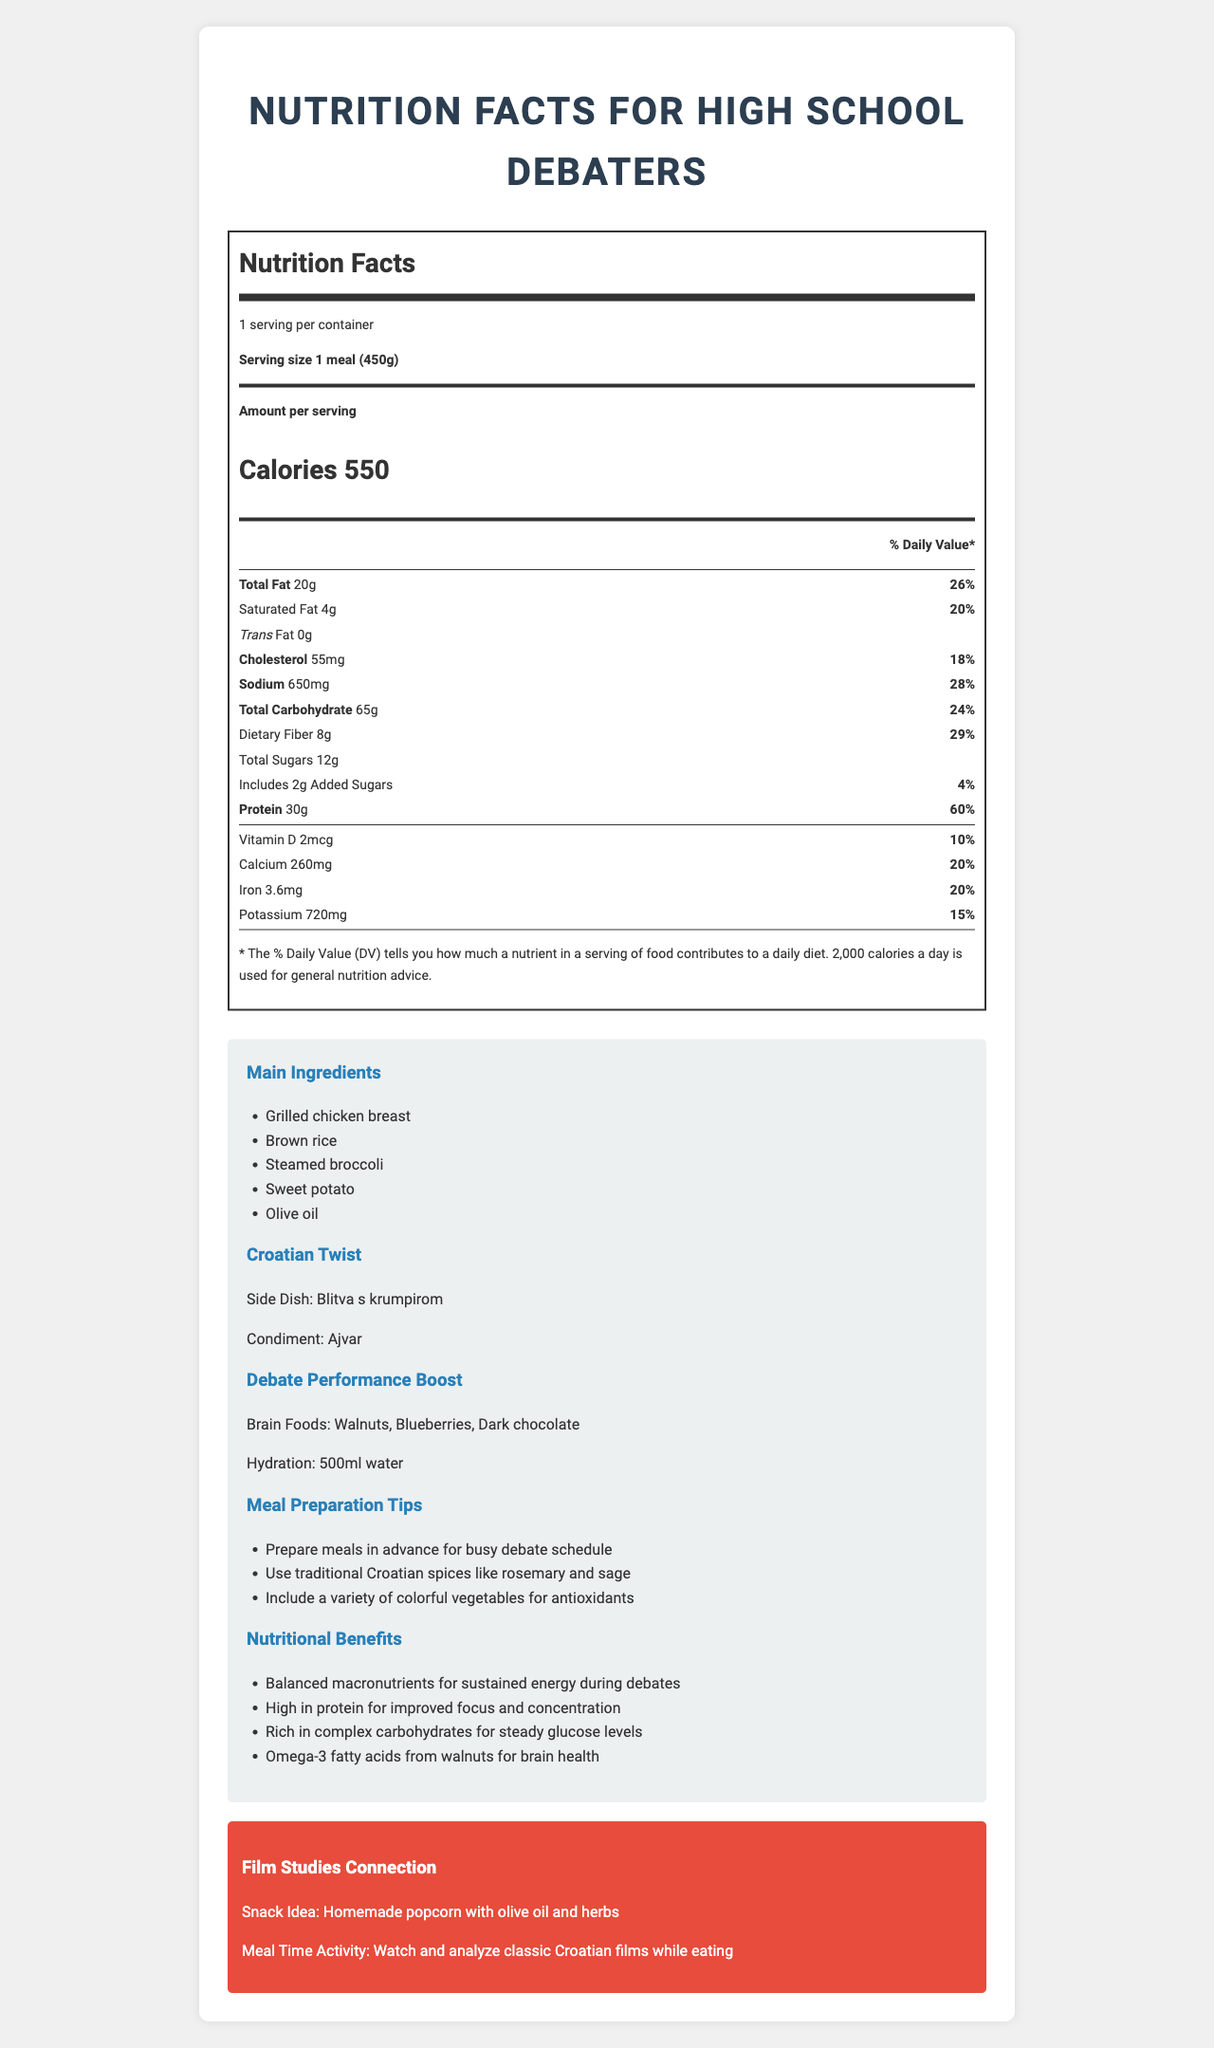What is the serving size for this meal? The document specifies the serving size as "1 meal (450g)" under the Nutrition Facts section.
Answer: 1 meal (450g) How many calories does one serving contain? The document states that one serving contains 550 calories.
Answer: 550 What is the main source of protein in this meal? According to the list of main ingredients, grilled chicken breast is mentioned first, indicating it is a primary ingredient and source of protein.
Answer: Grilled chicken breast What percentage of daily sodium intake does this meal provide? The document under the Sodium section shows that this meal provides 28% of the daily value for sodium.
Answer: 28% List three "brain foods" included in the meal to boost debate performance. The Debate Performance Boost section lists these foods specifically as brain foods.
Answer: Walnuts, Blueberries, Dark chocolate Which of the following is a condiment in the Croatian twist for this meal? A. Blitva s krumpirom B. Ajvar C. Olive oil D. Sweet potato The Croatian Twist section lists Ajvar as the condiment.
Answer: B How much added sugar is in one serving of this meal? The Nutrition Facts section includes the amount of added sugars, which is 2 grams.
Answer: 2g What is the main idea of the document? The document provides detailed nutritional facts, meal preparation tips, Croatian twists, and explains the benefits of the meal for high school debaters, including brain foods and hydration suggestions.
Answer: Nutritional information and benefits for a balanced meal designed for high school debaters Does this meal include any trans fat? The document specifies that the amount of trans fat in the meal is 0 grams.
Answer: No How much dietary fiber does one serving contain? The Nutrition Facts section under Dietary Fiber indicates that one serving contains 8 grams of dietary fiber.
Answer: 8g Can you determine the price of the meal from the document? The document provides nutritional information and preparation tips but does not include any pricing information.
Answer: Cannot be determined Which activity is suggested to engage in while eating this meal? A. Playing sports B. Watching and analyzing classic Croatian films C. Studying math D. Reading a book The Film Studies Connection section suggests watching and analyzing classic Croatian films while eating.
Answer: B Identify one nutritional benefit of the meal. The Nutritional Benefits section lists several benefits, including that the meal is high in protein, which is beneficial for focus and concentration.
Answer: High in protein for improved focus and concentration Which traditional Croatian spices are recommended for this meal? A. Rosemary B. Sage C. Oregano D. Both A and B The Meal Preparation Tips section recommends using traditional Croatian spices like rosemary and sage.
Answer: D What is the side dish mentioned in the Croatian twist? The Croatian Twist section includes Blitva s krumpirom as the side dish.
Answer: Blitva s krumpirom How much Vitamin D does this meal provide in micrograms? The Nutrition Facts section under Vitamin D specifies that this meal provides 2 micrograms of Vitamin D.
Answer: 2 mcg 